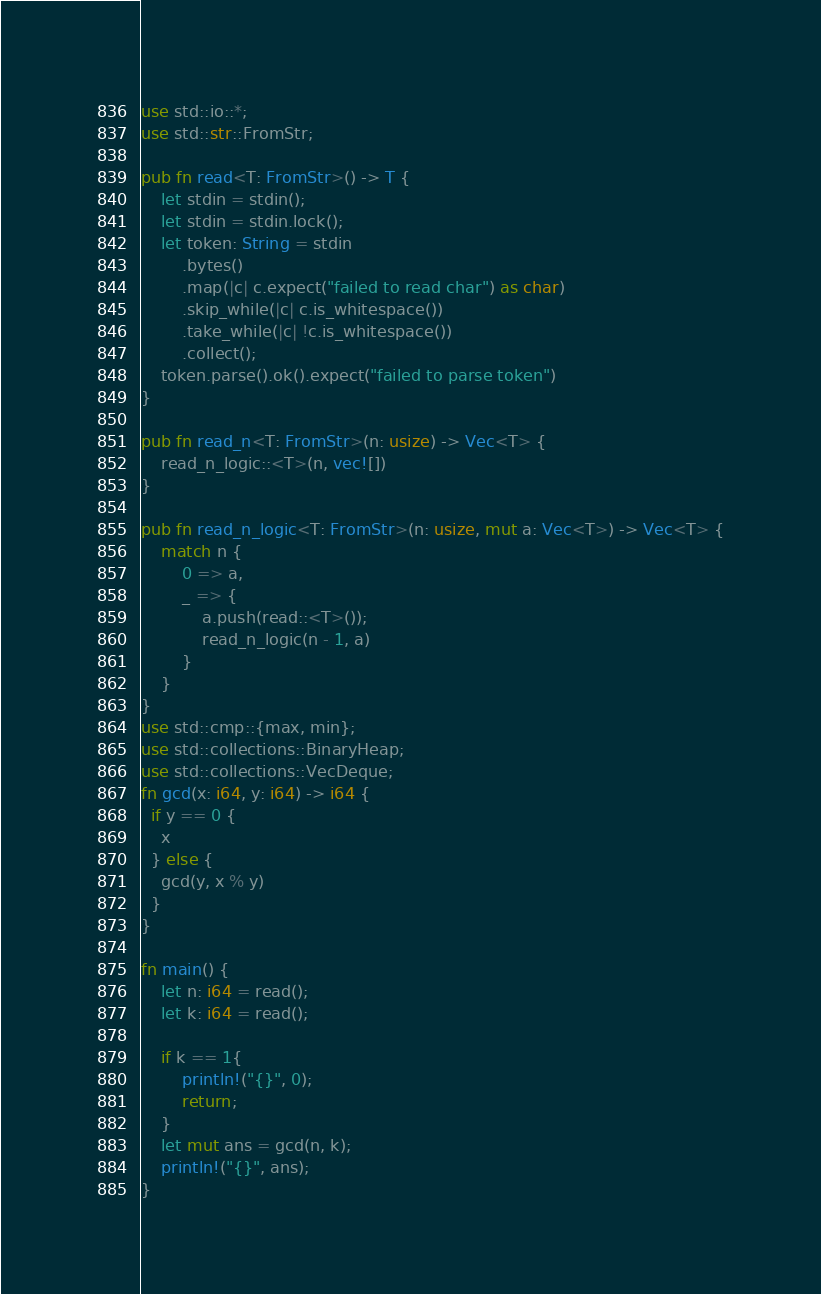<code> <loc_0><loc_0><loc_500><loc_500><_Rust_>use std::io::*;
use std::str::FromStr;

pub fn read<T: FromStr>() -> T {
    let stdin = stdin();
    let stdin = stdin.lock();
    let token: String = stdin
        .bytes()
        .map(|c| c.expect("failed to read char") as char)
        .skip_while(|c| c.is_whitespace())
        .take_while(|c| !c.is_whitespace())
        .collect();
    token.parse().ok().expect("failed to parse token")
}

pub fn read_n<T: FromStr>(n: usize) -> Vec<T> {
    read_n_logic::<T>(n, vec![])
}

pub fn read_n_logic<T: FromStr>(n: usize, mut a: Vec<T>) -> Vec<T> {
    match n {
        0 => a,
        _ => {
            a.push(read::<T>());
            read_n_logic(n - 1, a)
        }
    }
}
use std::cmp::{max, min};
use std::collections::BinaryHeap;
use std::collections::VecDeque;
fn gcd(x: i64, y: i64) -> i64 {
  if y == 0 {
    x
  } else {
    gcd(y, x % y)
  }
}

fn main() {
    let n: i64 = read();
    let k: i64 = read();

    if k == 1{
        println!("{}", 0);
        return;
    }
    let mut ans = gcd(n, k);
    println!("{}", ans);
}
</code> 